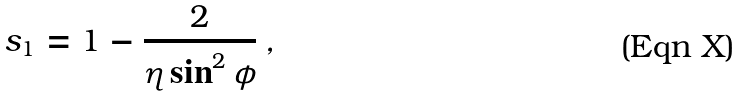Convert formula to latex. <formula><loc_0><loc_0><loc_500><loc_500>s _ { 1 } = 1 - \frac { 2 } { \eta \sin ^ { 2 } \phi } \, ,</formula> 